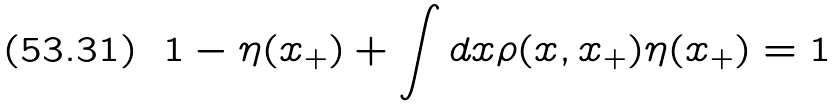<formula> <loc_0><loc_0><loc_500><loc_500>1 - \eta ( x _ { + } ) + \int d x \rho ( x , x _ { + } ) \eta ( x _ { + } ) = 1</formula> 